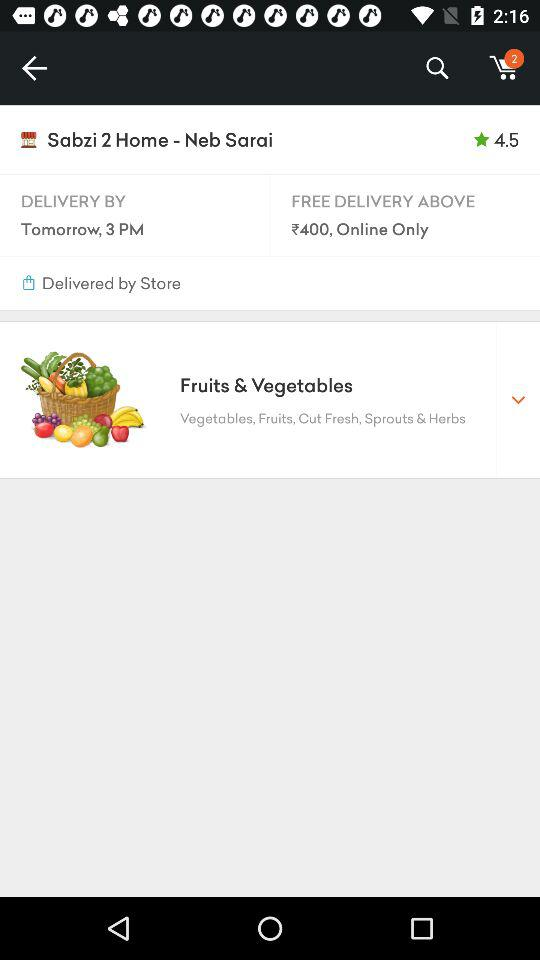Who is placing the food order?
When the provided information is insufficient, respond with <no answer>. <no answer> 